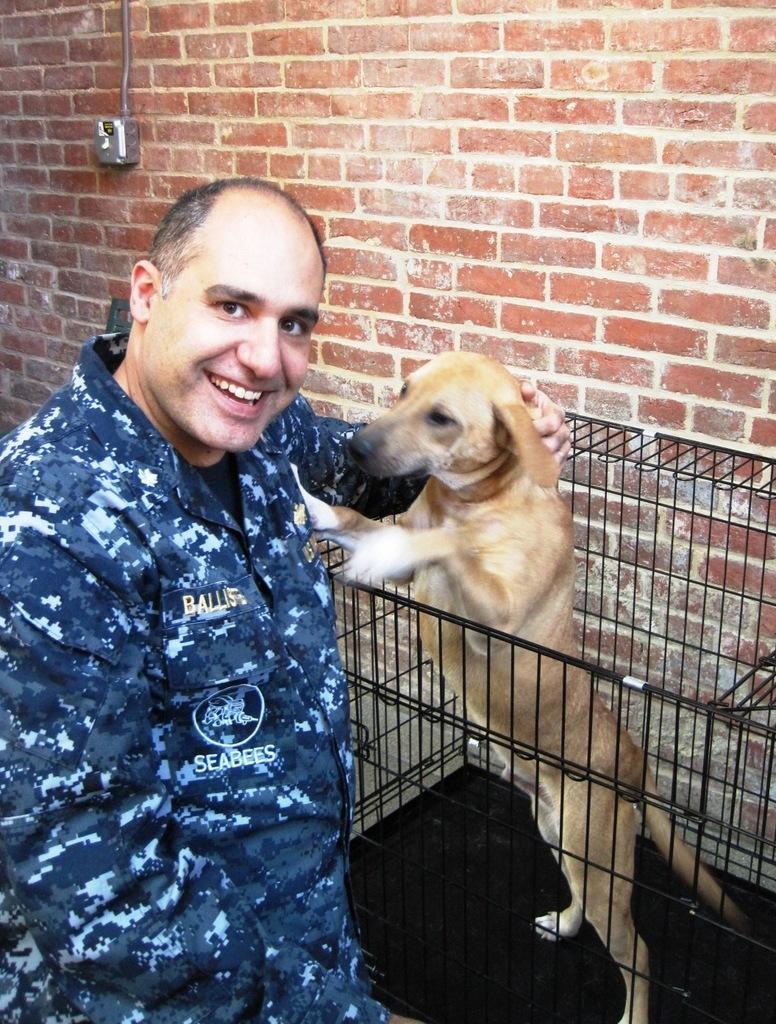Could you give a brief overview of what you see in this image? In this image we can see a person wearing a uniform is standing and smiling. Here we can see a dog in the cage. In the background, we can see the brick wall. 